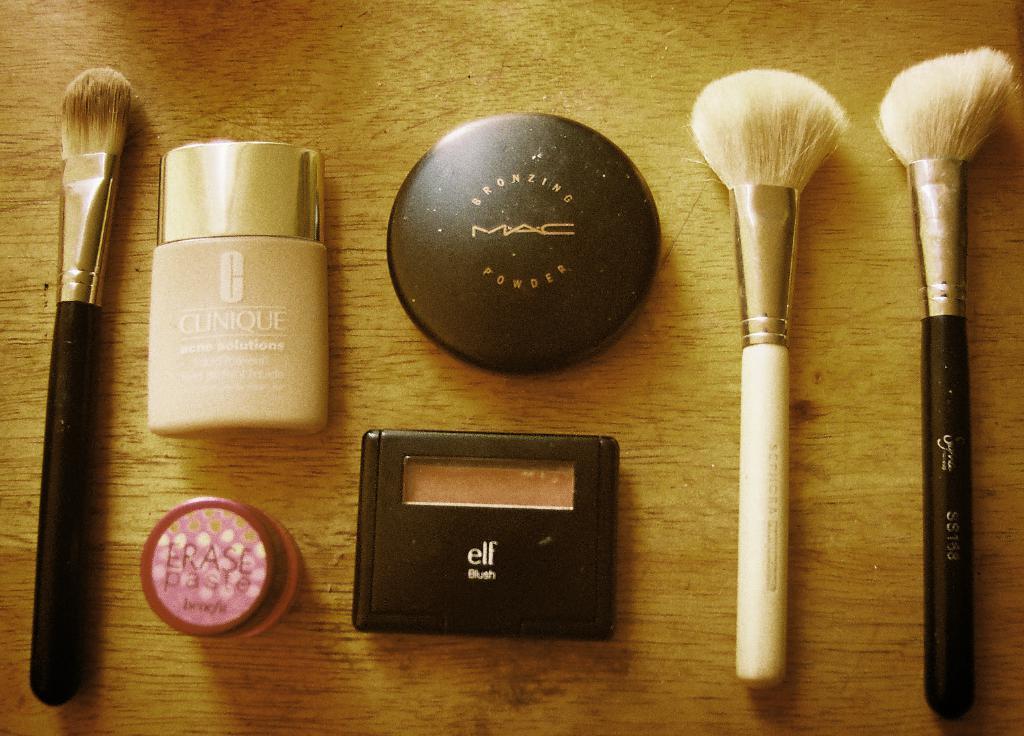Can you describe this image briefly? In this picture we can see brushes and makeup objects on the wooden platform. 